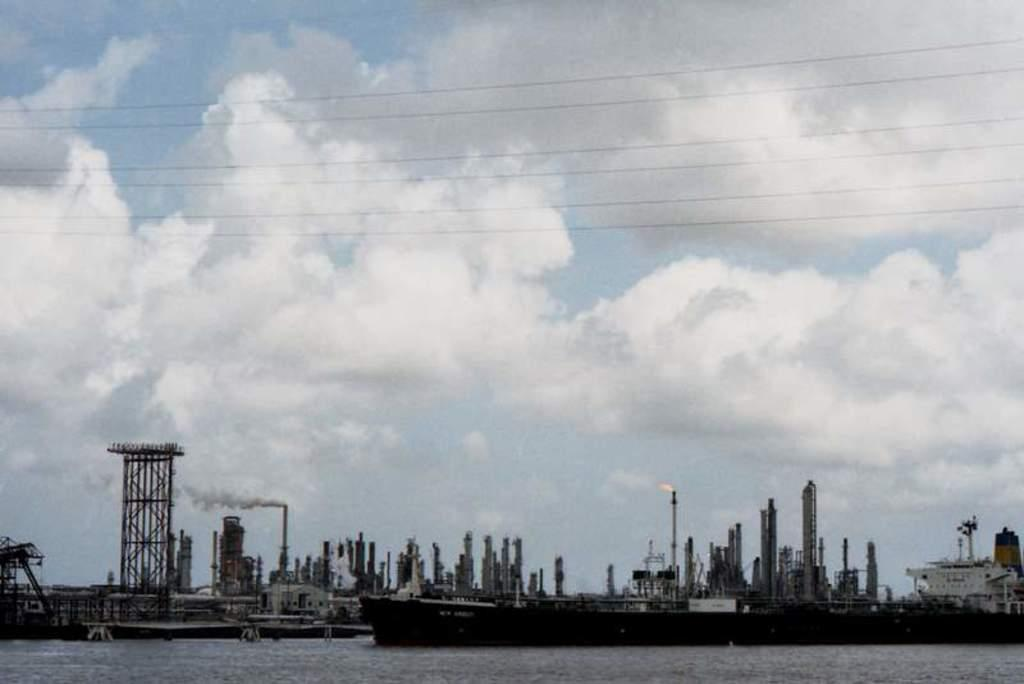What is located above the water in the image? There are ships above the water in the image. What can be seen coming from the ships in the image? There is smoke and fire visible in the image. What else is present in the image besides the ships and smoke? There are wires in the image. What is visible in the background of the image? The sky is visible in the background of the image, and there are clouds in the sky. What type of school can be seen in the image? There is no school present in the image. How does the police force contribute to the scene in the image? There is no police force present in the image. 